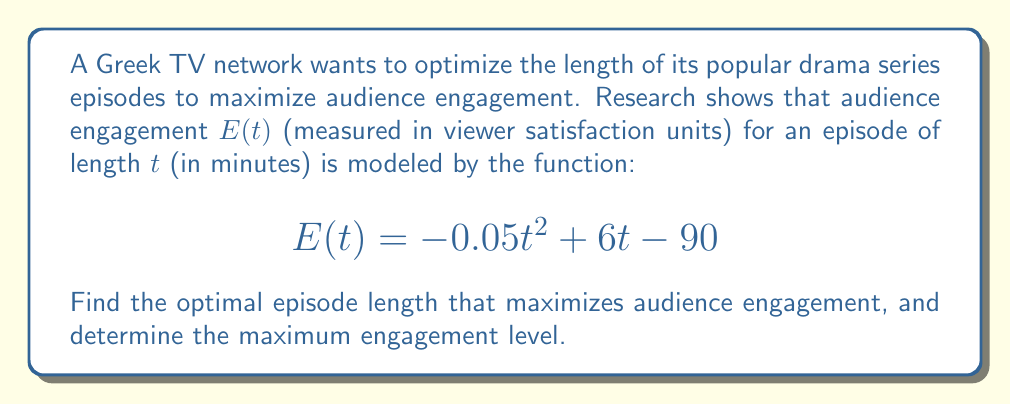Solve this math problem. To find the optimal episode length and maximum engagement, we need to follow these steps:

1. Identify the function: $E(t) = -0.05t^2 + 6t - 90$

2. Find the derivative of $E(t)$:
   $$\frac{dE}{dt} = -0.1t + 6$$

3. Set the derivative equal to zero to find the critical point:
   $$-0.1t + 6 = 0$$
   $$-0.1t = -6$$
   $$t = 60$$

4. Verify it's a maximum by checking the second derivative:
   $$\frac{d^2E}{dt^2} = -0.1$$
   Since this is negative, the critical point is a maximum.

5. Calculate the maximum engagement by plugging $t = 60$ into the original function:
   $$E(60) = -0.05(60)^2 + 6(60) - 90$$
   $$= -0.05(3600) + 360 - 90$$
   $$= -180 + 360 - 90$$
   $$= 90$$

Therefore, the optimal episode length is 60 minutes, and the maximum engagement level is 90 viewer satisfaction units.
Answer: Optimal length: 60 minutes; Maximum engagement: 90 units 